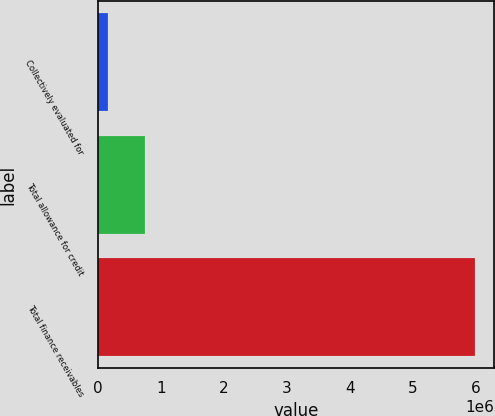<chart> <loc_0><loc_0><loc_500><loc_500><bar_chart><fcel>Collectively evaluated for<fcel>Total allowance for credit<fcel>Total finance receivables<nl><fcel>166761<fcel>748306<fcel>5.98221e+06<nl></chart> 